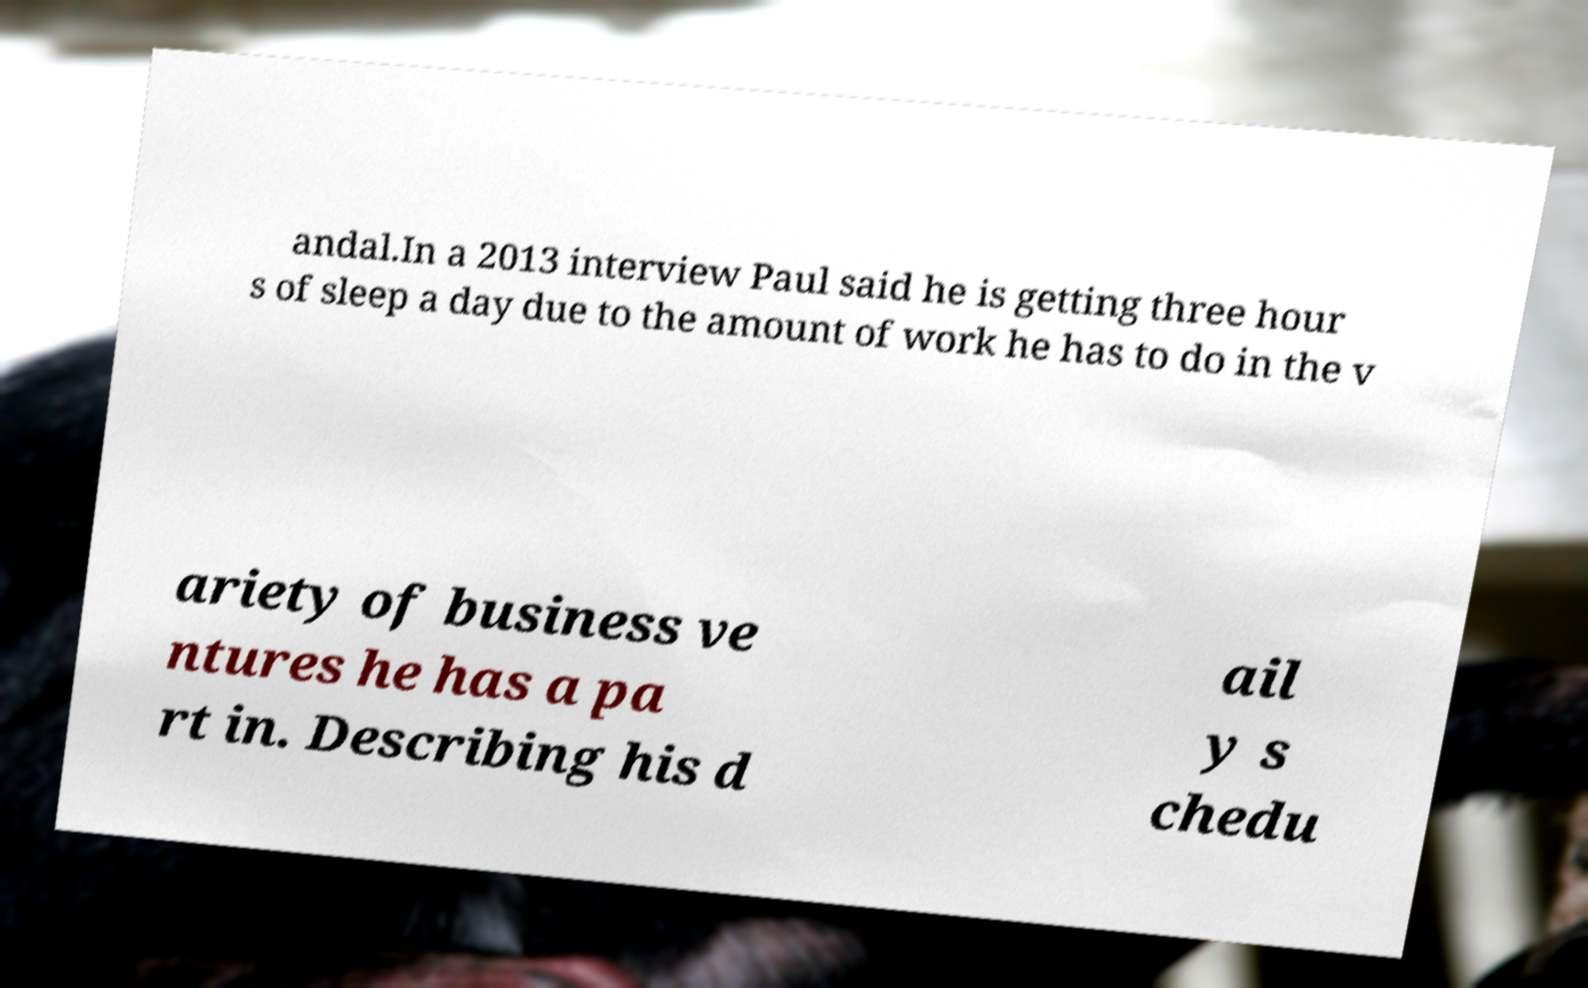Can you accurately transcribe the text from the provided image for me? andal.In a 2013 interview Paul said he is getting three hour s of sleep a day due to the amount of work he has to do in the v ariety of business ve ntures he has a pa rt in. Describing his d ail y s chedu 